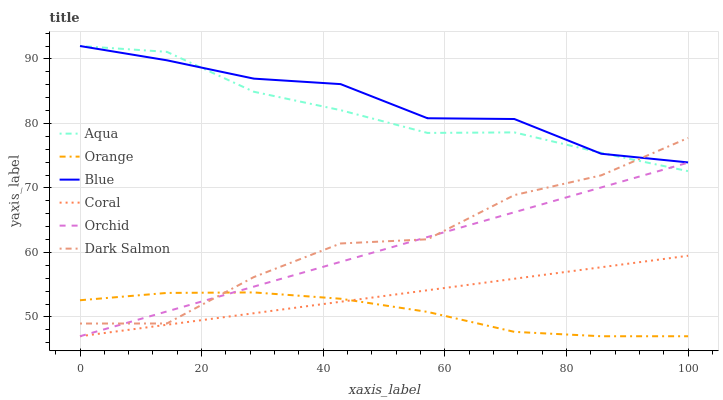Does Orange have the minimum area under the curve?
Answer yes or no. Yes. Does Blue have the maximum area under the curve?
Answer yes or no. Yes. Does Coral have the minimum area under the curve?
Answer yes or no. No. Does Coral have the maximum area under the curve?
Answer yes or no. No. Is Coral the smoothest?
Answer yes or no. Yes. Is Dark Salmon the roughest?
Answer yes or no. Yes. Is Aqua the smoothest?
Answer yes or no. No. Is Aqua the roughest?
Answer yes or no. No. Does Coral have the lowest value?
Answer yes or no. Yes. Does Aqua have the lowest value?
Answer yes or no. No. Does Aqua have the highest value?
Answer yes or no. Yes. Does Coral have the highest value?
Answer yes or no. No. Is Orange less than Aqua?
Answer yes or no. Yes. Is Dark Salmon greater than Coral?
Answer yes or no. Yes. Does Dark Salmon intersect Aqua?
Answer yes or no. Yes. Is Dark Salmon less than Aqua?
Answer yes or no. No. Is Dark Salmon greater than Aqua?
Answer yes or no. No. Does Orange intersect Aqua?
Answer yes or no. No. 